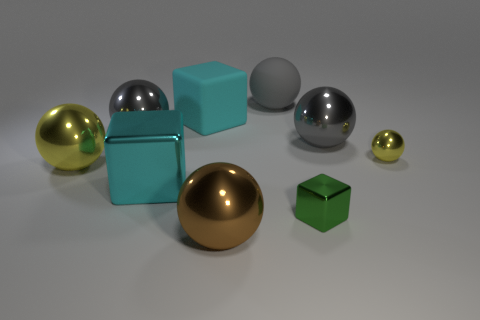What shape is the big object that is the same color as the tiny metal ball?
Give a very brief answer. Sphere. There is a metal object that is the same color as the rubber block; what size is it?
Your answer should be compact. Large. What is the color of the large rubber thing that is on the left side of the big brown metal ball?
Offer a very short reply. Cyan. There is a big object right of the gray matte ball; does it have the same color as the large rubber ball?
Offer a terse response. Yes. What size is the cyan metallic thing that is the same shape as the green object?
Provide a succinct answer. Large. Are there any other things that have the same size as the green cube?
Your answer should be compact. Yes. What is the material of the cyan thing that is behind the small metallic thing that is on the right side of the tiny object that is in front of the big yellow thing?
Your answer should be very brief. Rubber. Is the number of big gray metallic things in front of the large brown sphere greater than the number of small green blocks on the left side of the tiny metallic cube?
Offer a very short reply. No. Do the brown metallic thing and the cyan rubber cube have the same size?
Offer a terse response. Yes. What is the color of the other matte thing that is the same shape as the brown thing?
Keep it short and to the point. Gray. 